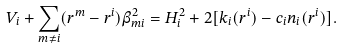<formula> <loc_0><loc_0><loc_500><loc_500>V _ { i } + \sum _ { m \neq i } ( r ^ { m } - r ^ { i } ) \beta _ { m i } ^ { 2 } = H _ { i } ^ { 2 } + 2 [ k _ { i } ( r ^ { i } ) - c _ { i } n _ { i } ( r ^ { i } ) ] .</formula> 